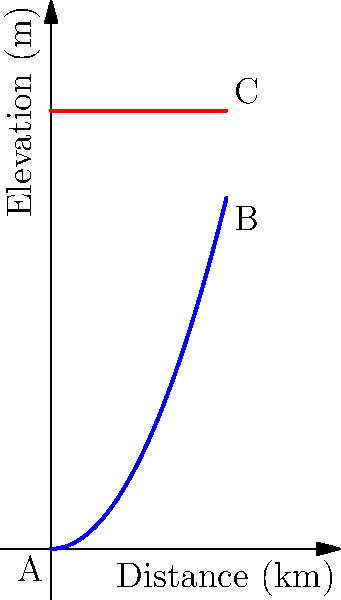A supply route from point A to point B follows a curved path represented by the equation $y = 0.1x^2$, where $y$ is the elevation in meters and $x$ is the distance in kilometers. An alternative straight route from A to C is available at a constant elevation of 50 meters. If fuel consumption increases by 0.5% for every 10 meters of elevation gain, calculate the difference in fuel consumption percentage between the curved and straight routes for a vehicle that normally consumes 30 liters of fuel per 100 km on flat terrain. Let's approach this step-by-step:

1) First, we need to calculate the elevation gain for the curved route (A to B):
   At x = 20 km, y = 0.1(20)^2 = 40 meters

2) The straight route (A to C) has a constant elevation of 50 meters, so the elevation gain is 50 meters.

3) Now, let's calculate the increase in fuel consumption for each route:

   Curved route (A to B):
   Elevation gain = 40 meters
   Fuel increase = (40 / 10) * 0.5% = 2%

   Straight route (A to C):
   Elevation gain = 50 meters
   Fuel increase = (50 / 10) * 0.5% = 2.5%

4) The difference in fuel consumption:
   2.5% - 2% = 0.5%

Therefore, the straight route consumes 0.5% more fuel than the curved route.
Answer: 0.5% 